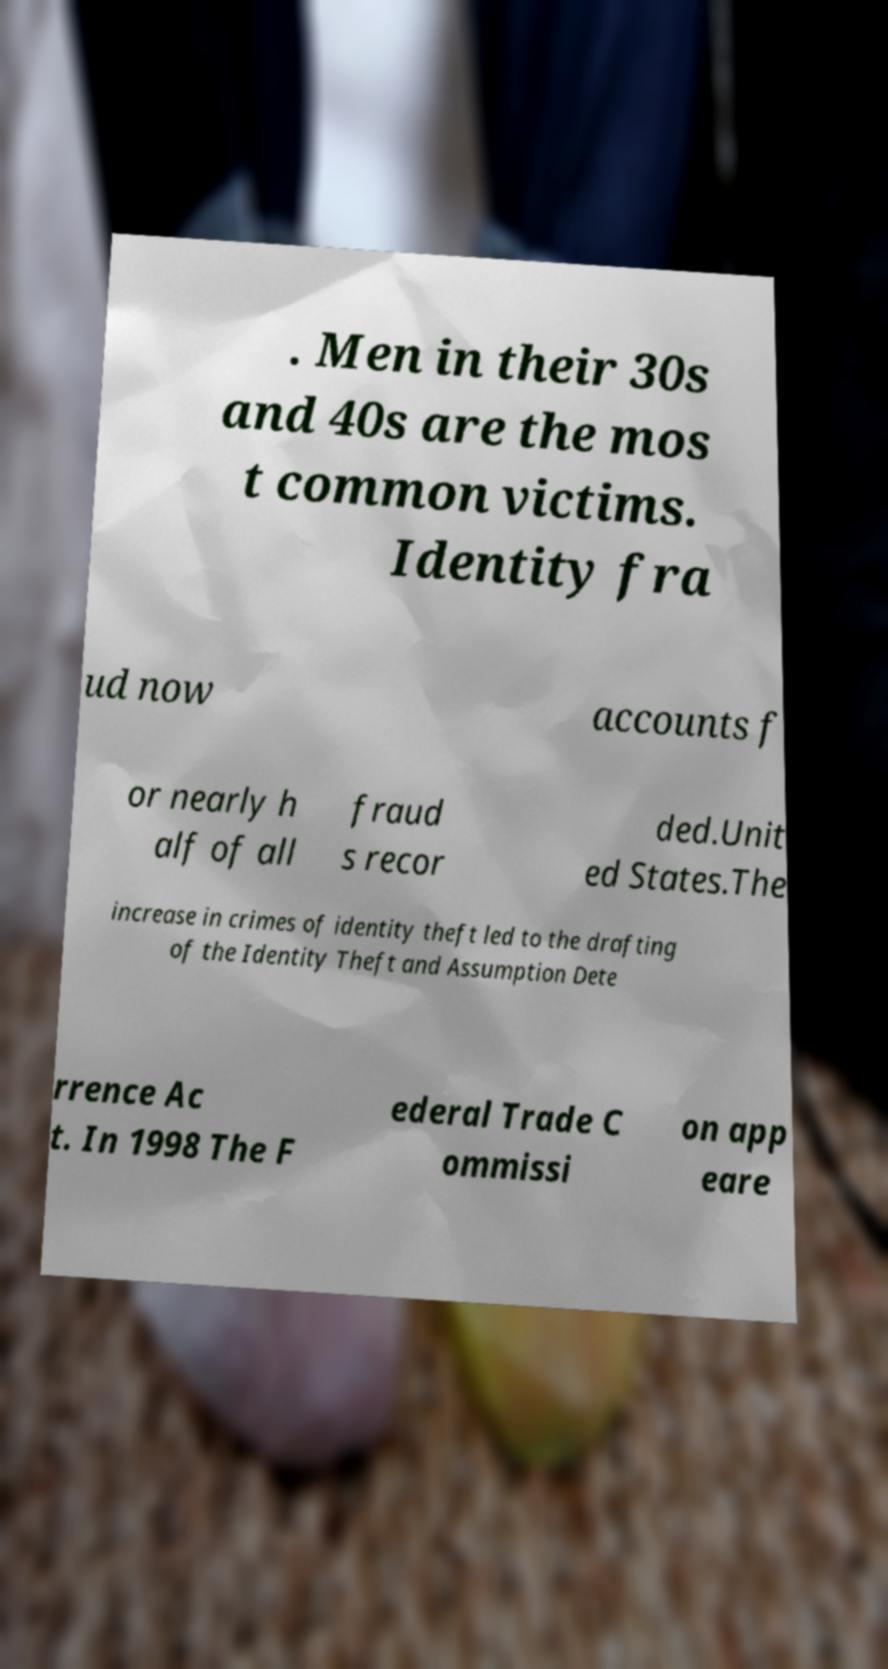Please identify and transcribe the text found in this image. . Men in their 30s and 40s are the mos t common victims. Identity fra ud now accounts f or nearly h alf of all fraud s recor ded.Unit ed States.The increase in crimes of identity theft led to the drafting of the Identity Theft and Assumption Dete rrence Ac t. In 1998 The F ederal Trade C ommissi on app eare 